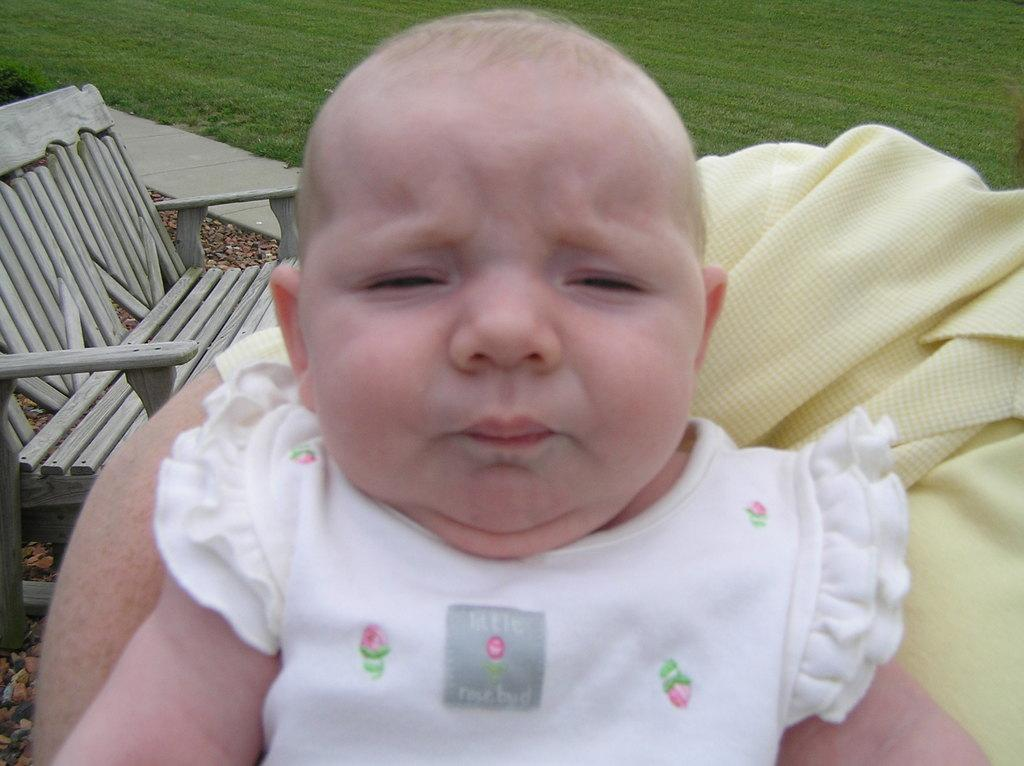What is the main subject of the picture? There is a baby in the picture. What can be seen on the left side of the picture? There is a wooden sofa on the left side of the picture. What type of surface is visible on the ground? Grass is visible on the ground. What color is the cloth in the picture? There is a yellow color cloth in the picture. Can you identify any other people in the picture besides the baby? There might be a woman in the picture. Where is the kitten hiding in the picture? There is no kitten present in the picture. What type of map can be seen on the wooden sofa? There is no map visible in the picture. 